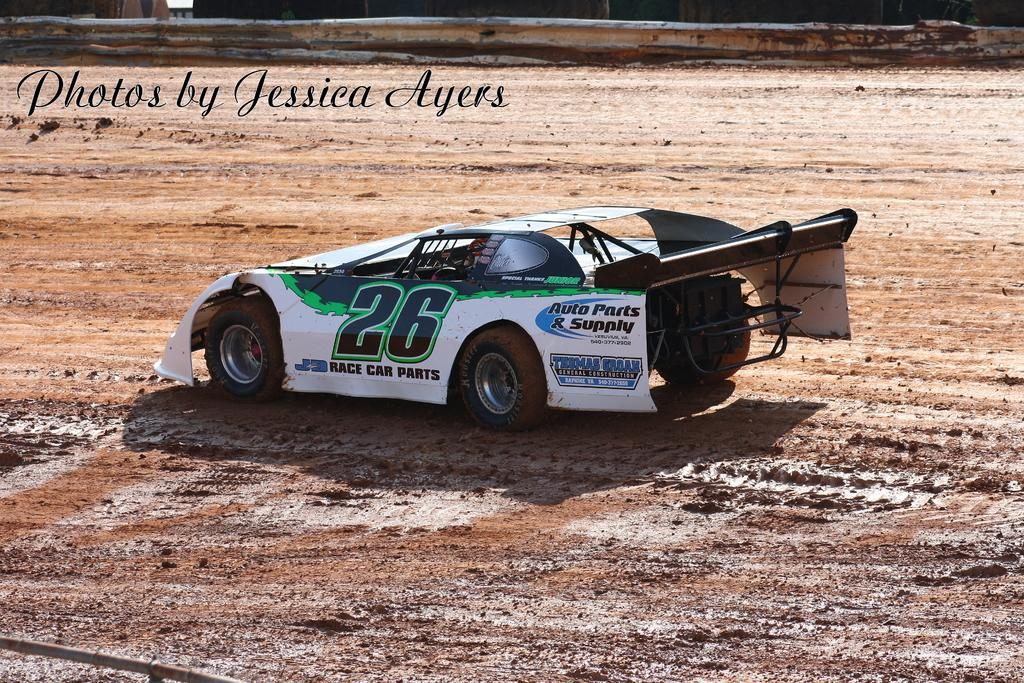What is the main subject in the center of the image? There is a car in the center of the image. What type of terrain is visible in the image? There is mud visible in the image. What can be seen at the top of the image? There is railing and text at the top of the image. What type of sand can be seen in the image? There is no sand present in the image; it features a car and mud. Can you describe the argument taking place in the image? There is no argument present in the image; it only shows a car, mud, railing, and text. 